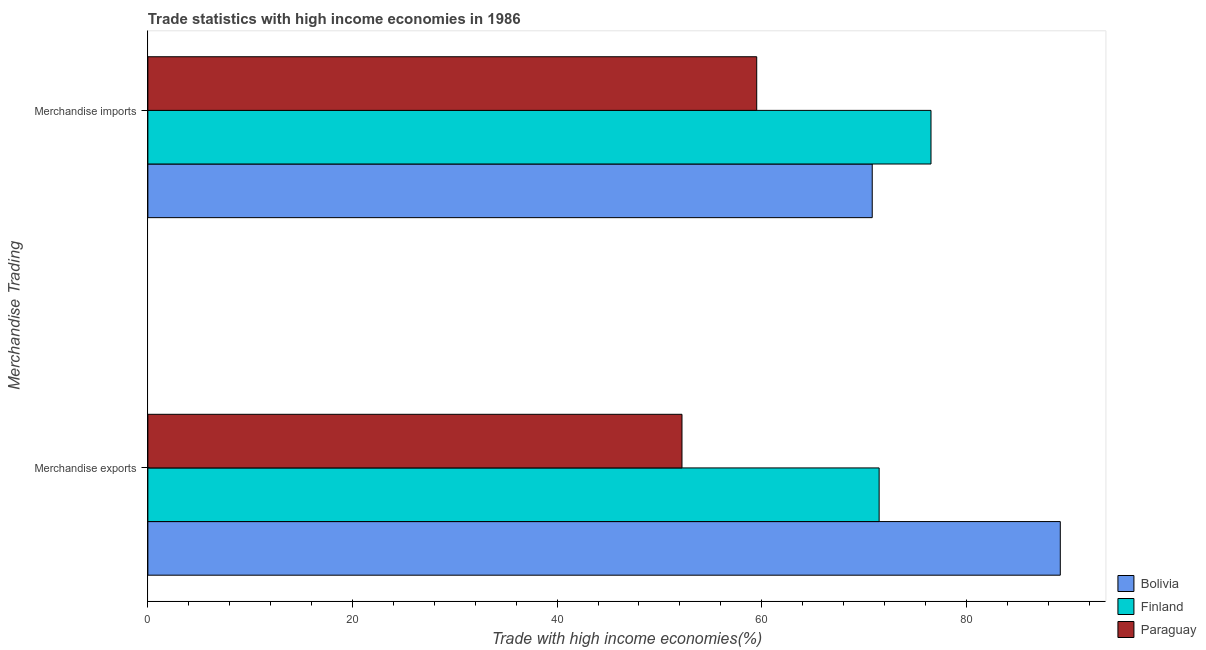Are the number of bars on each tick of the Y-axis equal?
Your answer should be compact. Yes. How many bars are there on the 1st tick from the top?
Offer a very short reply. 3. What is the label of the 1st group of bars from the top?
Keep it short and to the point. Merchandise imports. What is the merchandise exports in Paraguay?
Provide a short and direct response. 52.21. Across all countries, what is the maximum merchandise imports?
Provide a succinct answer. 76.55. Across all countries, what is the minimum merchandise exports?
Give a very brief answer. 52.21. In which country was the merchandise imports maximum?
Ensure brevity in your answer.  Finland. In which country was the merchandise exports minimum?
Ensure brevity in your answer.  Paraguay. What is the total merchandise imports in the graph?
Ensure brevity in your answer.  206.87. What is the difference between the merchandise exports in Paraguay and that in Bolivia?
Give a very brief answer. -36.98. What is the difference between the merchandise exports in Paraguay and the merchandise imports in Bolivia?
Your answer should be very brief. -18.6. What is the average merchandise imports per country?
Make the answer very short. 68.96. What is the difference between the merchandise imports and merchandise exports in Finland?
Your response must be concise. 5.07. In how many countries, is the merchandise exports greater than 20 %?
Your response must be concise. 3. What is the ratio of the merchandise imports in Bolivia to that in Finland?
Give a very brief answer. 0.92. What does the 2nd bar from the top in Merchandise imports represents?
Keep it short and to the point. Finland. What does the 3rd bar from the bottom in Merchandise imports represents?
Offer a terse response. Paraguay. How many bars are there?
Offer a terse response. 6. Are all the bars in the graph horizontal?
Offer a terse response. Yes. How many countries are there in the graph?
Make the answer very short. 3. Does the graph contain grids?
Provide a succinct answer. No. What is the title of the graph?
Offer a terse response. Trade statistics with high income economies in 1986. What is the label or title of the X-axis?
Make the answer very short. Trade with high income economies(%). What is the label or title of the Y-axis?
Your answer should be very brief. Merchandise Trading. What is the Trade with high income economies(%) of Bolivia in Merchandise exports?
Give a very brief answer. 89.19. What is the Trade with high income economies(%) in Finland in Merchandise exports?
Make the answer very short. 71.48. What is the Trade with high income economies(%) of Paraguay in Merchandise exports?
Give a very brief answer. 52.21. What is the Trade with high income economies(%) in Bolivia in Merchandise imports?
Your answer should be very brief. 70.81. What is the Trade with high income economies(%) in Finland in Merchandise imports?
Keep it short and to the point. 76.55. What is the Trade with high income economies(%) in Paraguay in Merchandise imports?
Provide a short and direct response. 59.51. Across all Merchandise Trading, what is the maximum Trade with high income economies(%) of Bolivia?
Offer a terse response. 89.19. Across all Merchandise Trading, what is the maximum Trade with high income economies(%) of Finland?
Your answer should be compact. 76.55. Across all Merchandise Trading, what is the maximum Trade with high income economies(%) of Paraguay?
Your response must be concise. 59.51. Across all Merchandise Trading, what is the minimum Trade with high income economies(%) in Bolivia?
Ensure brevity in your answer.  70.81. Across all Merchandise Trading, what is the minimum Trade with high income economies(%) in Finland?
Offer a terse response. 71.48. Across all Merchandise Trading, what is the minimum Trade with high income economies(%) in Paraguay?
Ensure brevity in your answer.  52.21. What is the total Trade with high income economies(%) of Bolivia in the graph?
Your answer should be very brief. 159.99. What is the total Trade with high income economies(%) of Finland in the graph?
Offer a terse response. 148.03. What is the total Trade with high income economies(%) of Paraguay in the graph?
Offer a terse response. 111.72. What is the difference between the Trade with high income economies(%) in Bolivia in Merchandise exports and that in Merchandise imports?
Your answer should be compact. 18.38. What is the difference between the Trade with high income economies(%) in Finland in Merchandise exports and that in Merchandise imports?
Your answer should be very brief. -5.07. What is the difference between the Trade with high income economies(%) of Paraguay in Merchandise exports and that in Merchandise imports?
Offer a terse response. -7.31. What is the difference between the Trade with high income economies(%) in Bolivia in Merchandise exports and the Trade with high income economies(%) in Finland in Merchandise imports?
Give a very brief answer. 12.64. What is the difference between the Trade with high income economies(%) of Bolivia in Merchandise exports and the Trade with high income economies(%) of Paraguay in Merchandise imports?
Offer a terse response. 29.67. What is the difference between the Trade with high income economies(%) in Finland in Merchandise exports and the Trade with high income economies(%) in Paraguay in Merchandise imports?
Give a very brief answer. 11.97. What is the average Trade with high income economies(%) of Bolivia per Merchandise Trading?
Give a very brief answer. 80. What is the average Trade with high income economies(%) of Finland per Merchandise Trading?
Keep it short and to the point. 74.02. What is the average Trade with high income economies(%) of Paraguay per Merchandise Trading?
Offer a very short reply. 55.86. What is the difference between the Trade with high income economies(%) of Bolivia and Trade with high income economies(%) of Finland in Merchandise exports?
Keep it short and to the point. 17.71. What is the difference between the Trade with high income economies(%) of Bolivia and Trade with high income economies(%) of Paraguay in Merchandise exports?
Make the answer very short. 36.98. What is the difference between the Trade with high income economies(%) in Finland and Trade with high income economies(%) in Paraguay in Merchandise exports?
Your answer should be very brief. 19.27. What is the difference between the Trade with high income economies(%) of Bolivia and Trade with high income economies(%) of Finland in Merchandise imports?
Provide a succinct answer. -5.74. What is the difference between the Trade with high income economies(%) in Bolivia and Trade with high income economies(%) in Paraguay in Merchandise imports?
Ensure brevity in your answer.  11.29. What is the difference between the Trade with high income economies(%) in Finland and Trade with high income economies(%) in Paraguay in Merchandise imports?
Give a very brief answer. 17.04. What is the ratio of the Trade with high income economies(%) in Bolivia in Merchandise exports to that in Merchandise imports?
Offer a terse response. 1.26. What is the ratio of the Trade with high income economies(%) in Finland in Merchandise exports to that in Merchandise imports?
Give a very brief answer. 0.93. What is the ratio of the Trade with high income economies(%) of Paraguay in Merchandise exports to that in Merchandise imports?
Offer a terse response. 0.88. What is the difference between the highest and the second highest Trade with high income economies(%) in Bolivia?
Ensure brevity in your answer.  18.38. What is the difference between the highest and the second highest Trade with high income economies(%) in Finland?
Your answer should be very brief. 5.07. What is the difference between the highest and the second highest Trade with high income economies(%) in Paraguay?
Provide a succinct answer. 7.31. What is the difference between the highest and the lowest Trade with high income economies(%) in Bolivia?
Give a very brief answer. 18.38. What is the difference between the highest and the lowest Trade with high income economies(%) of Finland?
Offer a terse response. 5.07. What is the difference between the highest and the lowest Trade with high income economies(%) of Paraguay?
Make the answer very short. 7.31. 